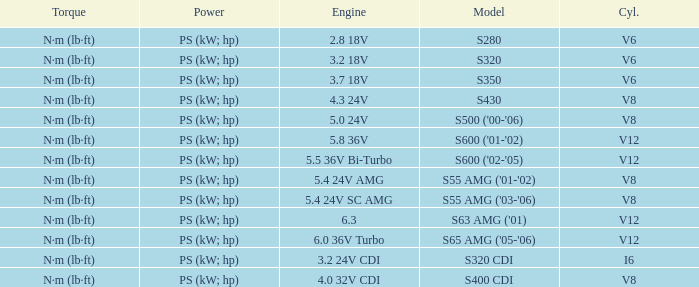Which Torque has a Model of s63 amg ('01)? N·m (lb·ft). 